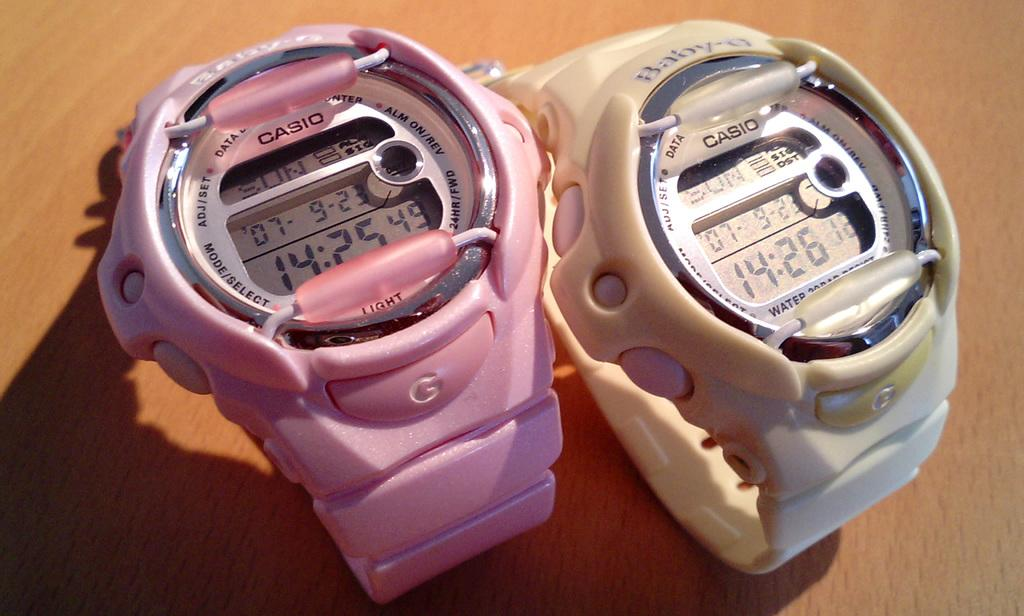<image>
Render a clear and concise summary of the photo. A pink Casio watch showing the time as 14:25 sits beside a white Casio watch showing the time as 14:26 